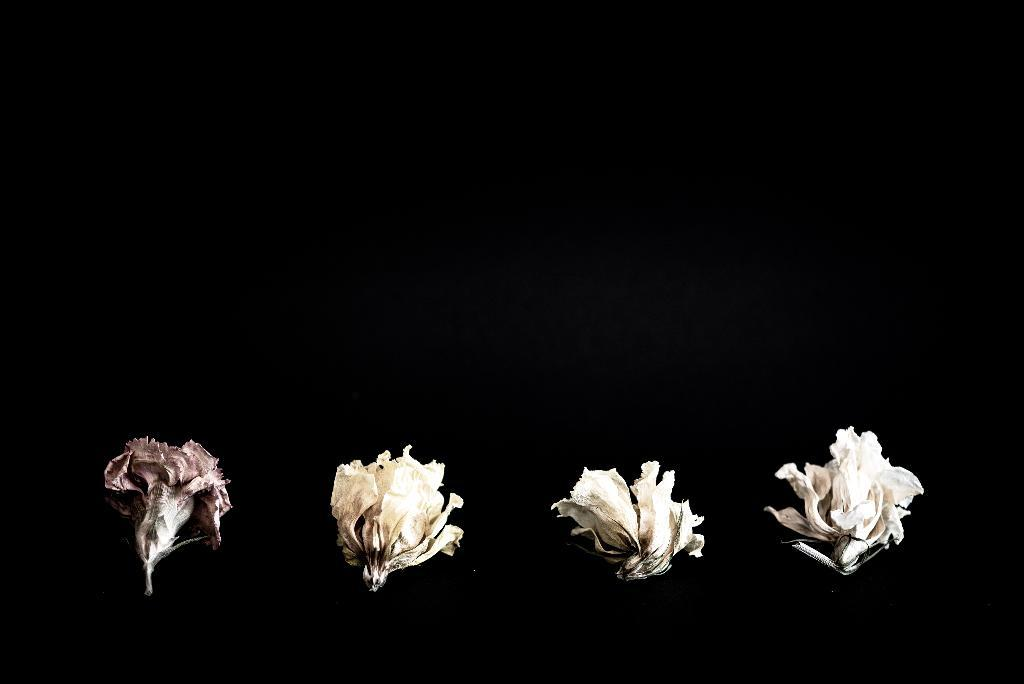What type of living organisms can be seen in the image? There are flowers in the image. What color is the background of the image? The background of the image is black. What type of destruction can be seen in the image? There is no destruction present in the image; it features flowers against a black background. Is there any indication of burning in the image? There is no indication of burning in the image; it features flowers against a black background. 